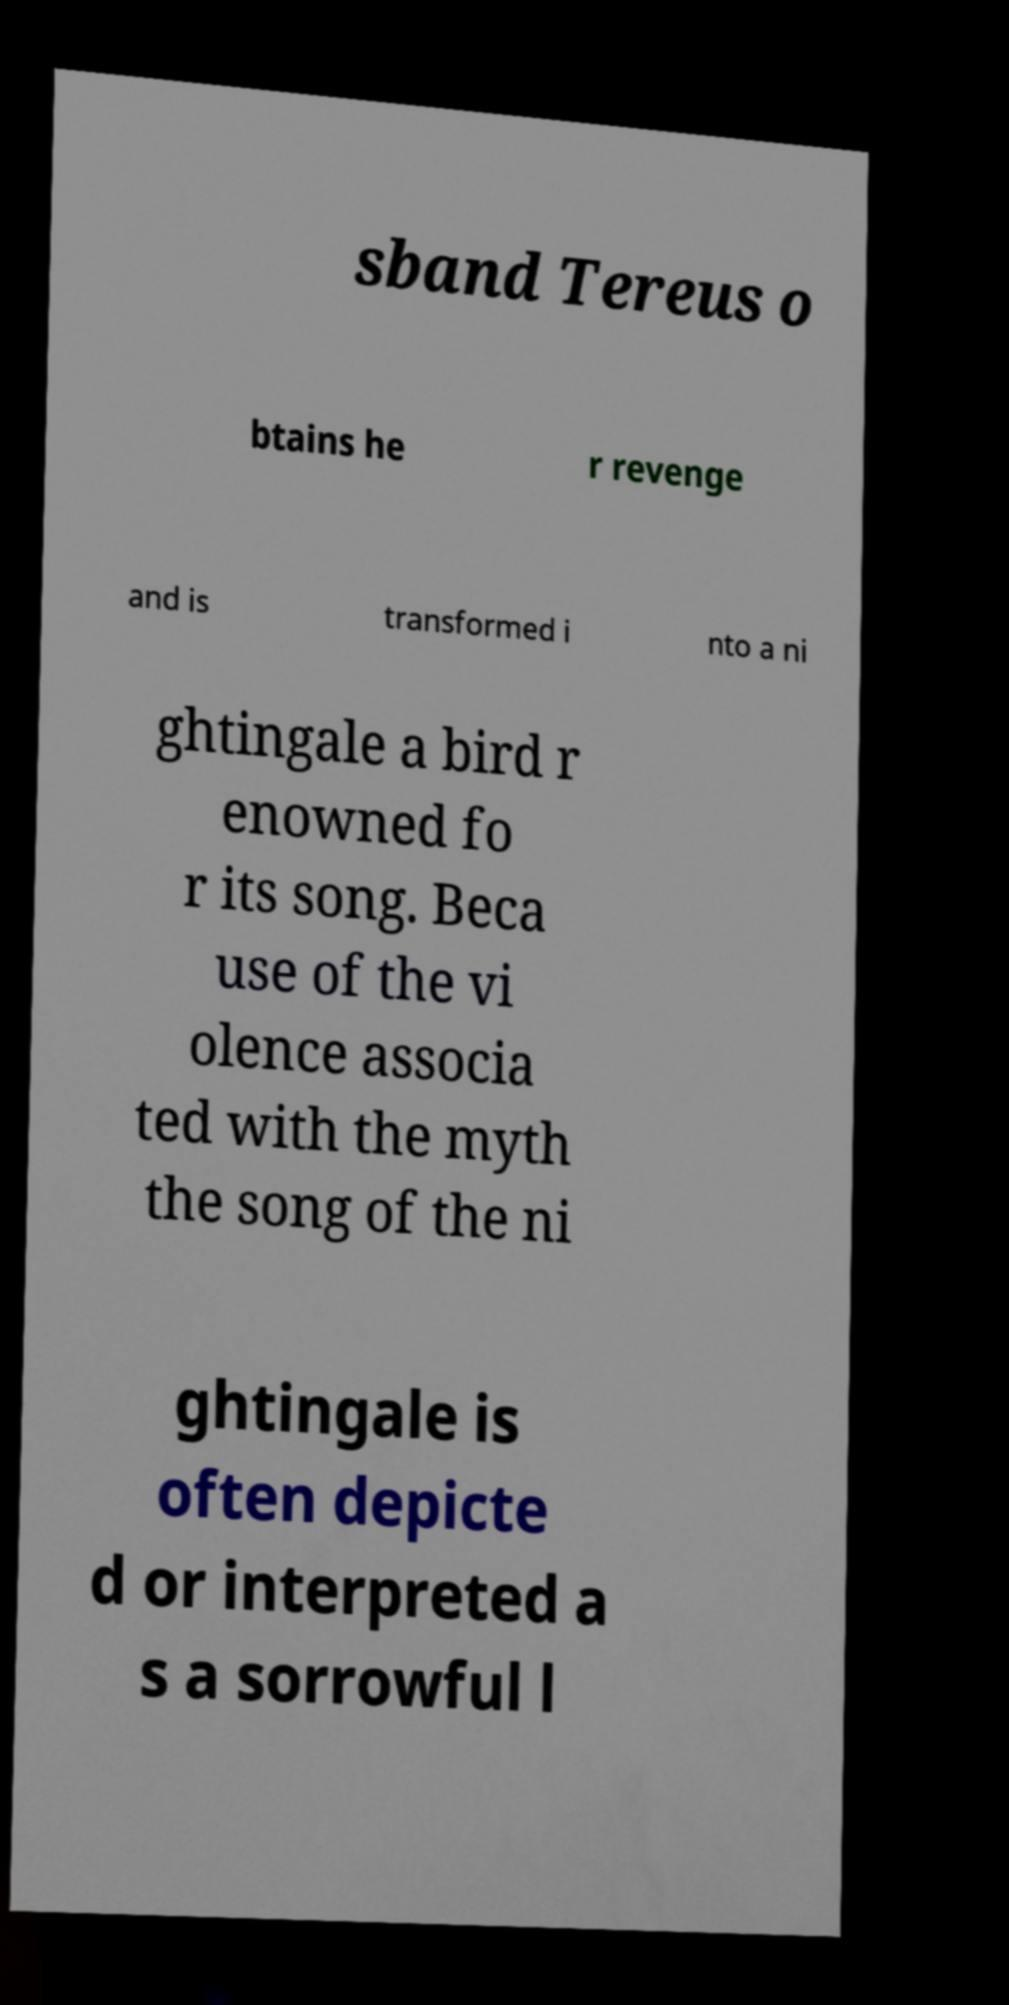Please identify and transcribe the text found in this image. sband Tereus o btains he r revenge and is transformed i nto a ni ghtingale a bird r enowned fo r its song. Beca use of the vi olence associa ted with the myth the song of the ni ghtingale is often depicte d or interpreted a s a sorrowful l 